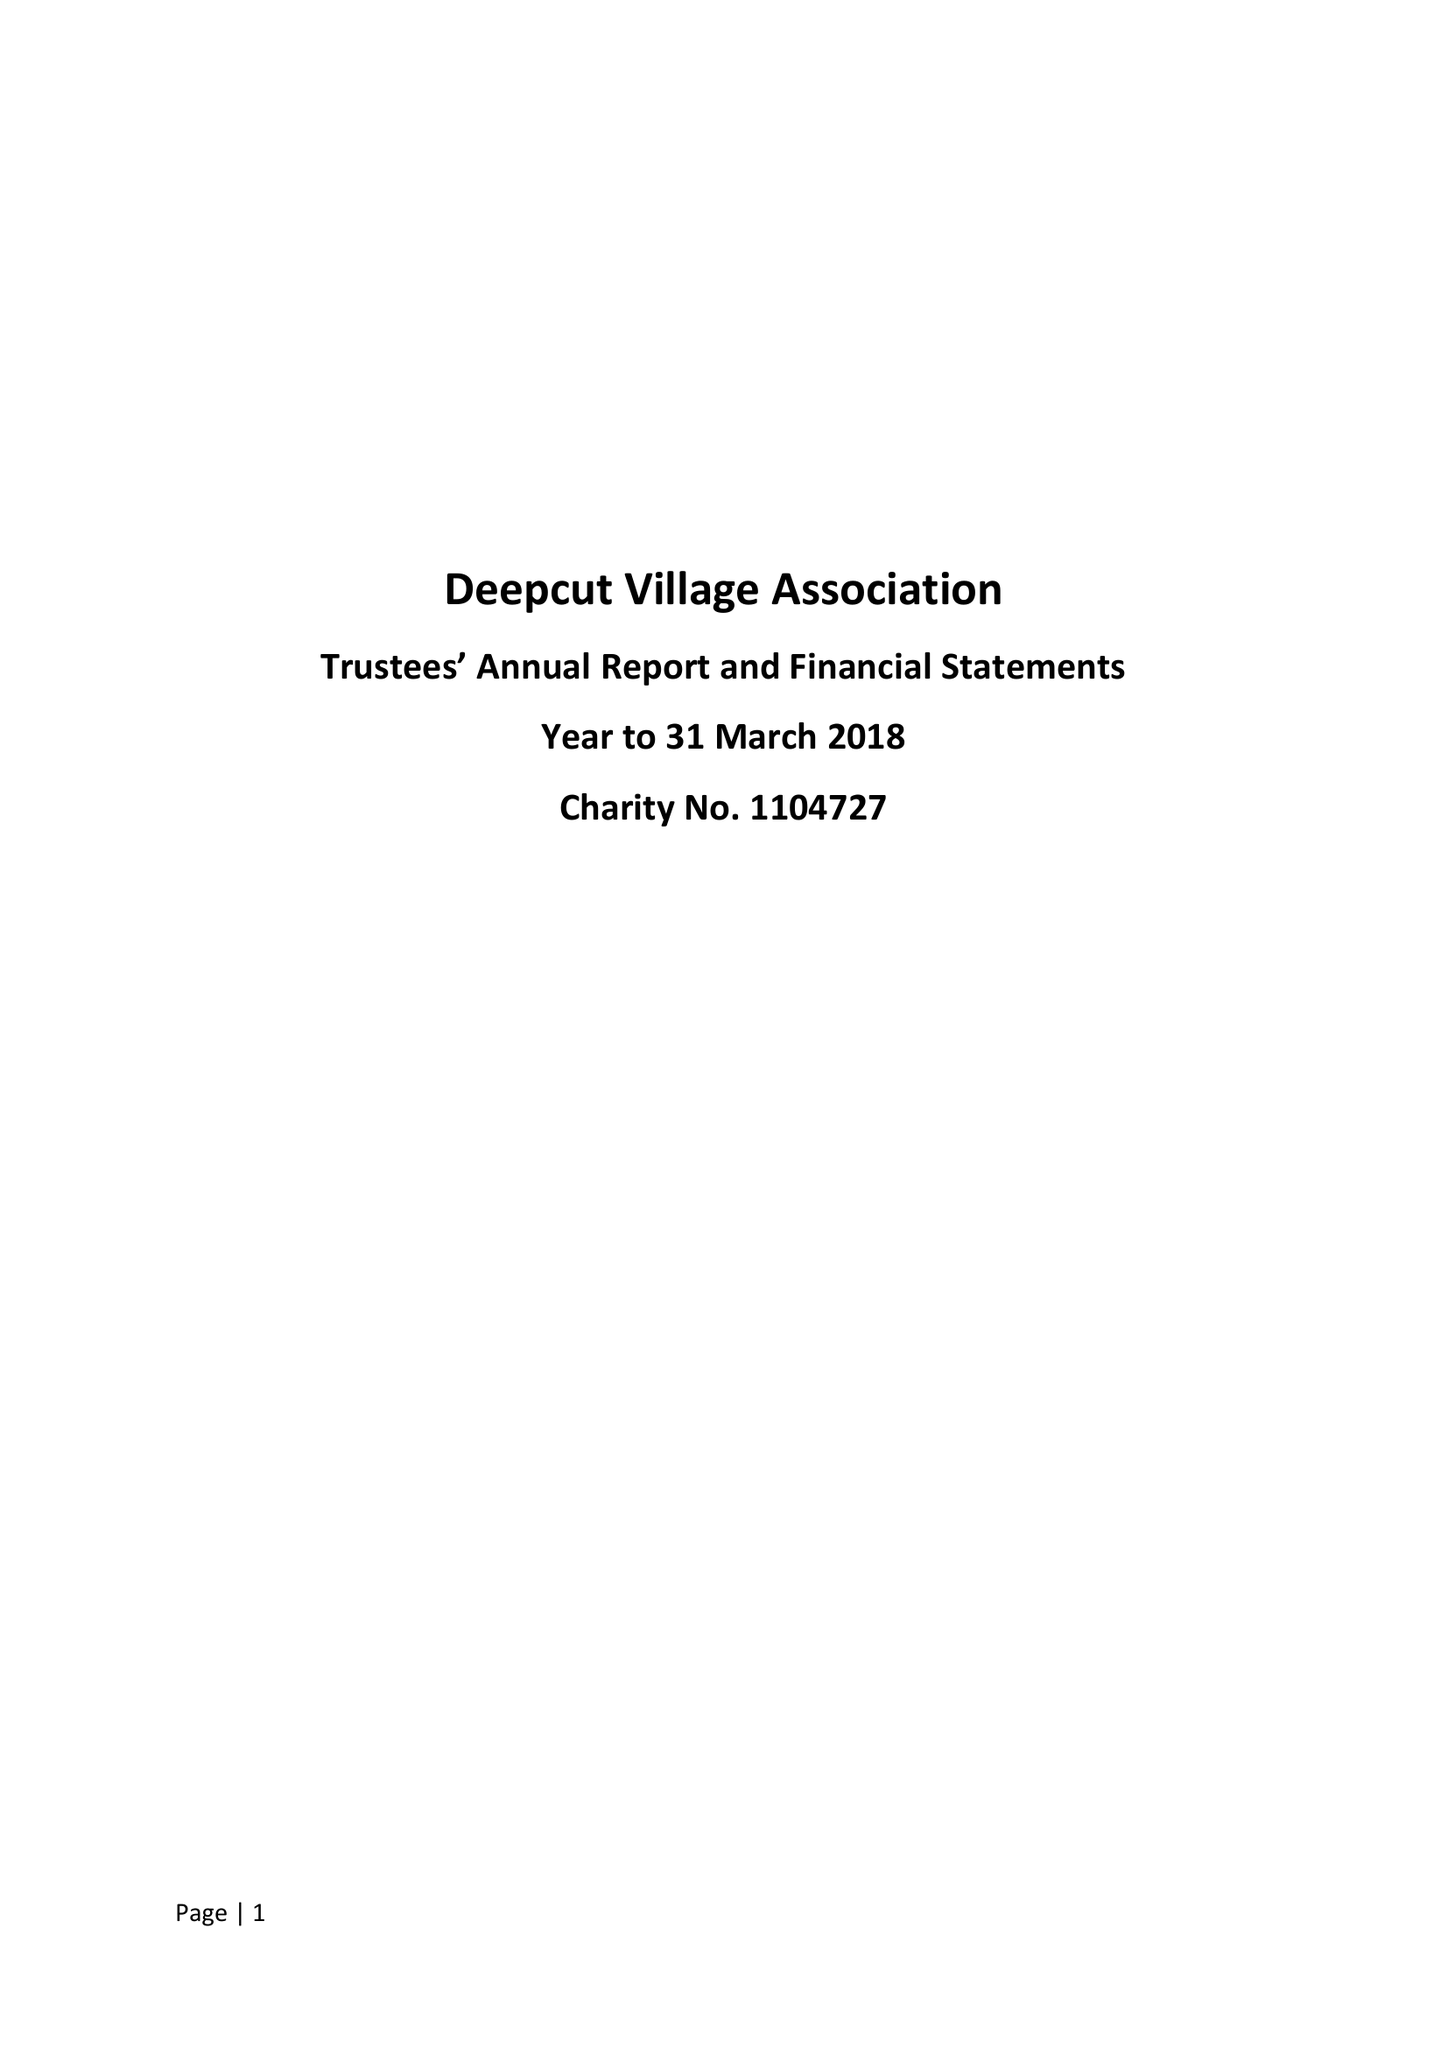What is the value for the address__postcode?
Answer the question using a single word or phrase. GU16 6BW 